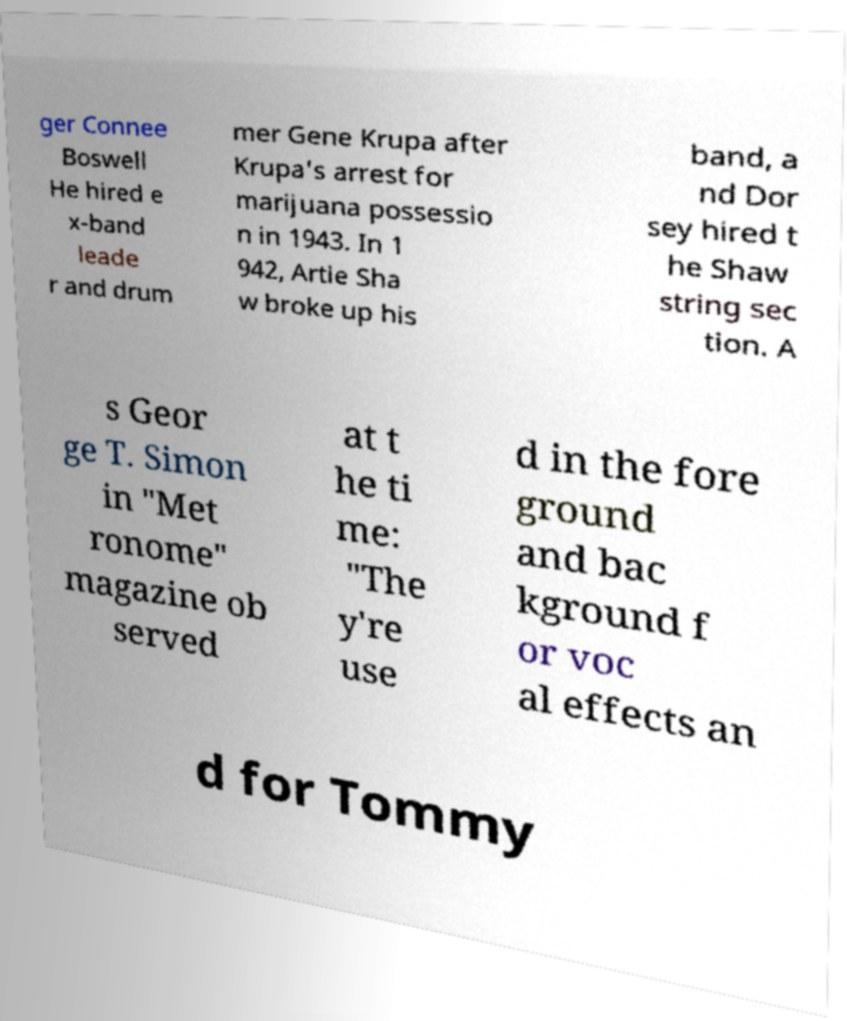There's text embedded in this image that I need extracted. Can you transcribe it verbatim? ger Connee Boswell He hired e x-band leade r and drum mer Gene Krupa after Krupa's arrest for marijuana possessio n in 1943. In 1 942, Artie Sha w broke up his band, a nd Dor sey hired t he Shaw string sec tion. A s Geor ge T. Simon in "Met ronome" magazine ob served at t he ti me: "The y're use d in the fore ground and bac kground f or voc al effects an d for Tommy 